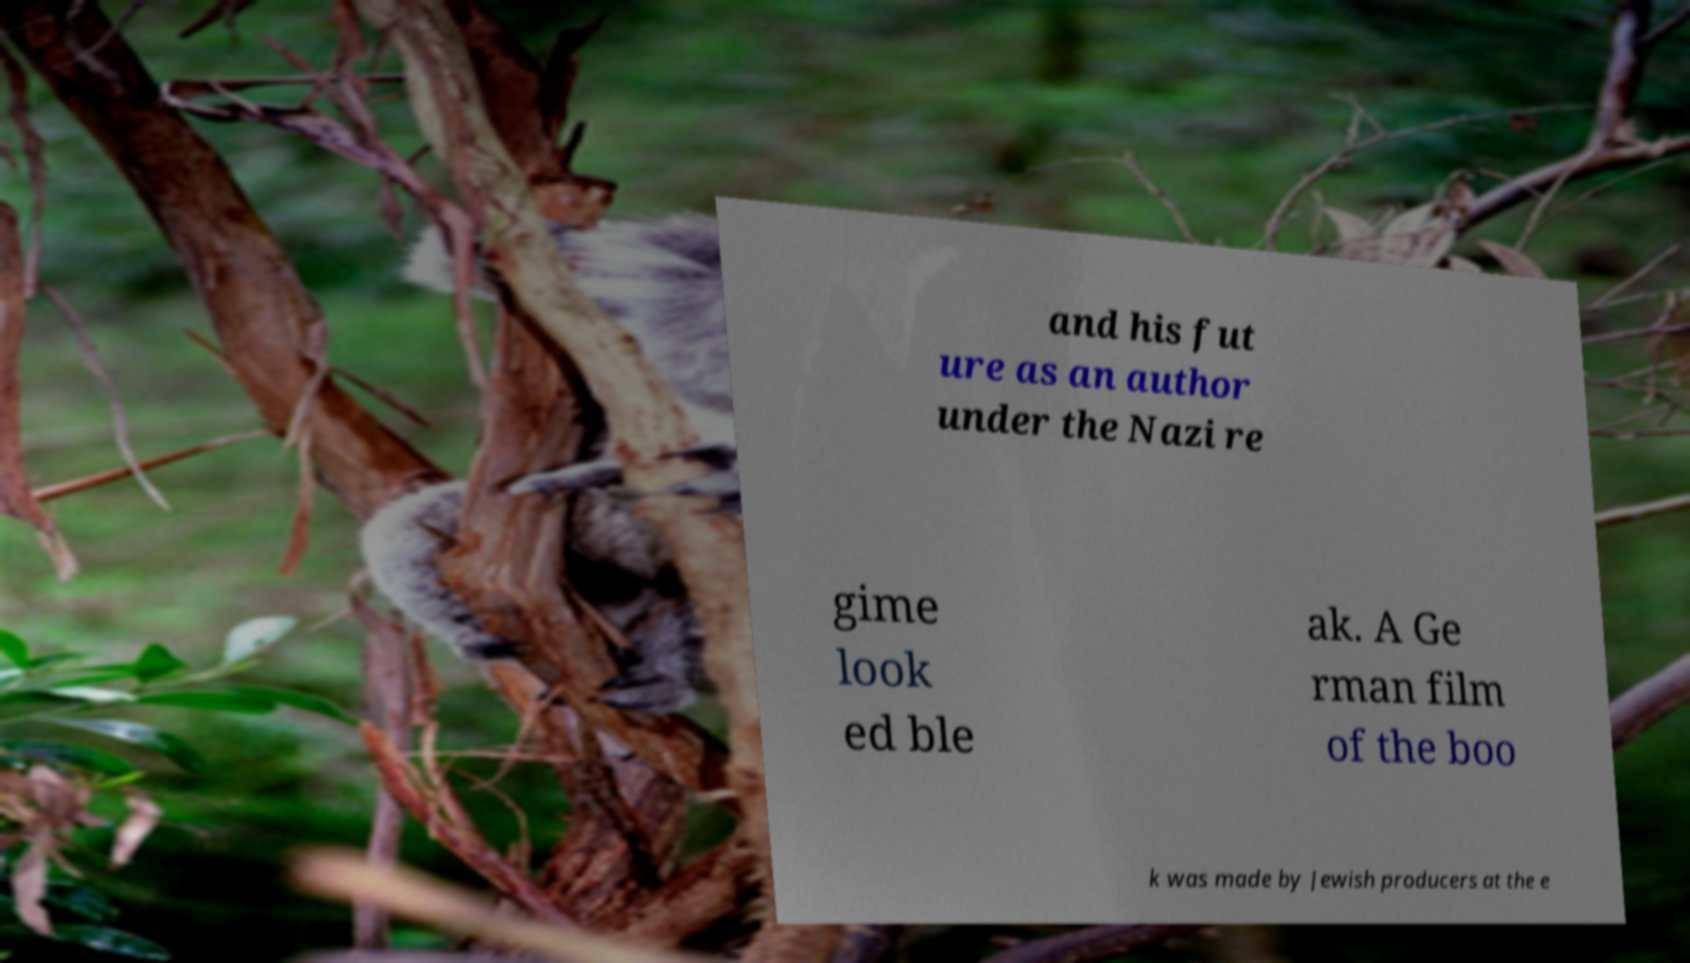What messages or text are displayed in this image? I need them in a readable, typed format. and his fut ure as an author under the Nazi re gime look ed ble ak. A Ge rman film of the boo k was made by Jewish producers at the e 